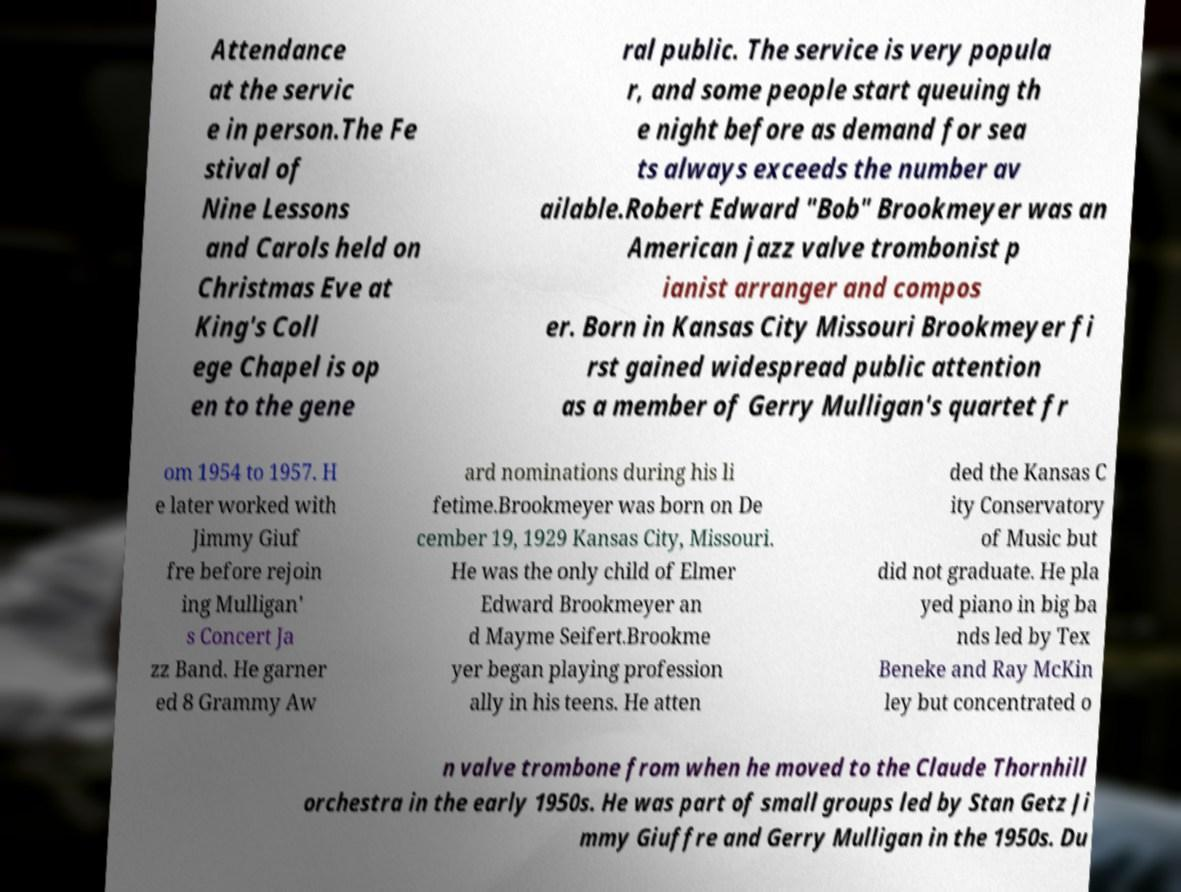For documentation purposes, I need the text within this image transcribed. Could you provide that? Attendance at the servic e in person.The Fe stival of Nine Lessons and Carols held on Christmas Eve at King's Coll ege Chapel is op en to the gene ral public. The service is very popula r, and some people start queuing th e night before as demand for sea ts always exceeds the number av ailable.Robert Edward "Bob" Brookmeyer was an American jazz valve trombonist p ianist arranger and compos er. Born in Kansas City Missouri Brookmeyer fi rst gained widespread public attention as a member of Gerry Mulligan's quartet fr om 1954 to 1957. H e later worked with Jimmy Giuf fre before rejoin ing Mulligan' s Concert Ja zz Band. He garner ed 8 Grammy Aw ard nominations during his li fetime.Brookmeyer was born on De cember 19, 1929 Kansas City, Missouri. He was the only child of Elmer Edward Brookmeyer an d Mayme Seifert.Brookme yer began playing profession ally in his teens. He atten ded the Kansas C ity Conservatory of Music but did not graduate. He pla yed piano in big ba nds led by Tex Beneke and Ray McKin ley but concentrated o n valve trombone from when he moved to the Claude Thornhill orchestra in the early 1950s. He was part of small groups led by Stan Getz Ji mmy Giuffre and Gerry Mulligan in the 1950s. Du 